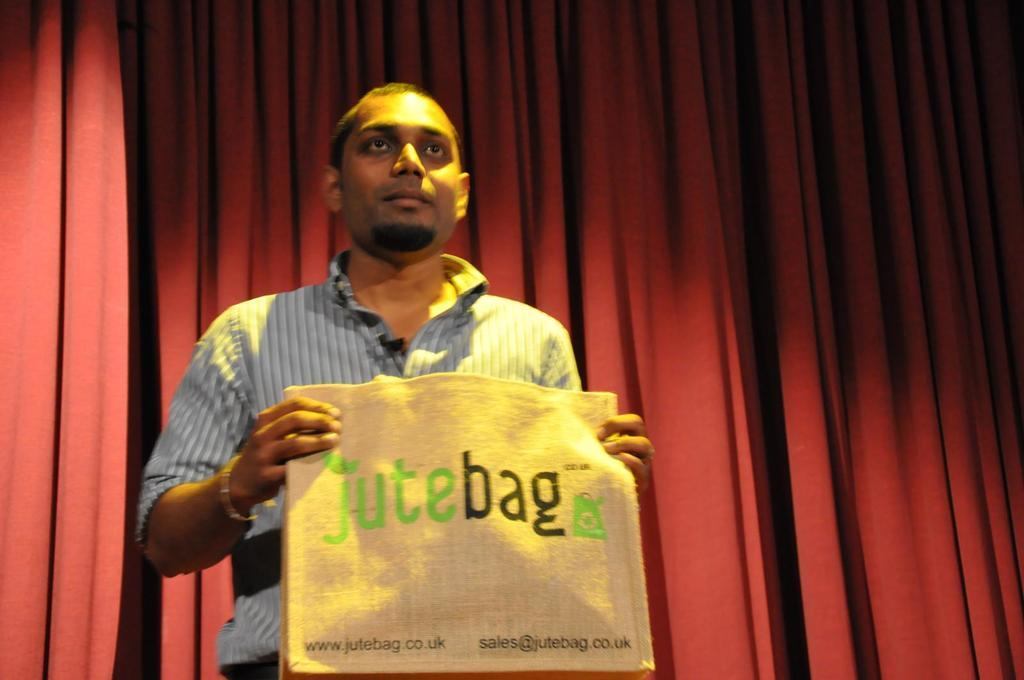Who is present in the image? There is a man in the image. What is the man holding in the image? The man is holding a jute bag. What can be seen on the jute bag? The jute bag has text on it. What is visible in the background of the image? There is a curtain in the background of the image. What type of cherry is the man eating in the image? There is no cherry present in the image, and the man is not eating anything. 